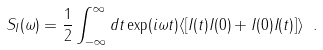<formula> <loc_0><loc_0><loc_500><loc_500>S _ { I } ( \omega ) = \frac { 1 } { 2 } \int _ { - \infty } ^ { \infty } d t \exp ( i \omega t ) \langle [ I ( t ) I ( 0 ) + I ( 0 ) I ( t ) ] \rangle \ .</formula> 